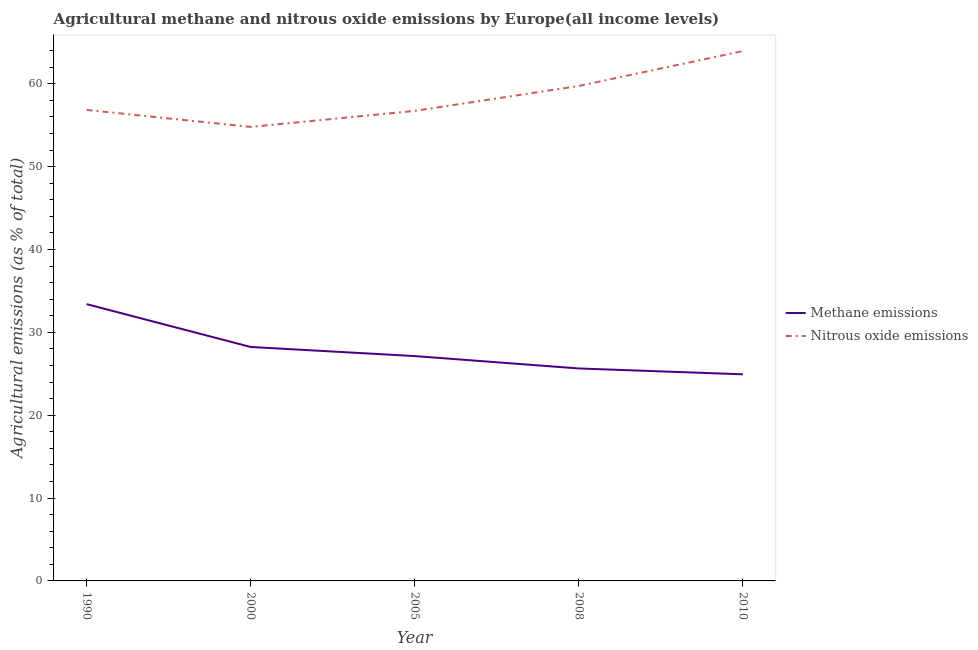Is the number of lines equal to the number of legend labels?
Offer a very short reply. Yes. What is the amount of nitrous oxide emissions in 2000?
Give a very brief answer. 54.8. Across all years, what is the maximum amount of methane emissions?
Provide a short and direct response. 33.41. Across all years, what is the minimum amount of nitrous oxide emissions?
Provide a short and direct response. 54.8. In which year was the amount of nitrous oxide emissions maximum?
Provide a succinct answer. 2010. In which year was the amount of nitrous oxide emissions minimum?
Provide a short and direct response. 2000. What is the total amount of methane emissions in the graph?
Your answer should be compact. 139.38. What is the difference between the amount of methane emissions in 2000 and that in 2010?
Ensure brevity in your answer.  3.3. What is the difference between the amount of methane emissions in 2008 and the amount of nitrous oxide emissions in 2000?
Offer a terse response. -29.16. What is the average amount of methane emissions per year?
Offer a very short reply. 27.88. In the year 2008, what is the difference between the amount of methane emissions and amount of nitrous oxide emissions?
Your response must be concise. -34.1. In how many years, is the amount of nitrous oxide emissions greater than 18 %?
Your answer should be very brief. 5. What is the ratio of the amount of methane emissions in 1990 to that in 2008?
Your answer should be very brief. 1.3. Is the amount of methane emissions in 2008 less than that in 2010?
Provide a short and direct response. No. What is the difference between the highest and the second highest amount of nitrous oxide emissions?
Make the answer very short. 4.21. What is the difference between the highest and the lowest amount of methane emissions?
Offer a very short reply. 8.47. Is the sum of the amount of nitrous oxide emissions in 1990 and 2008 greater than the maximum amount of methane emissions across all years?
Ensure brevity in your answer.  Yes. Does the amount of nitrous oxide emissions monotonically increase over the years?
Your answer should be compact. No. Is the amount of methane emissions strictly less than the amount of nitrous oxide emissions over the years?
Your answer should be very brief. Yes. How many lines are there?
Give a very brief answer. 2. How many years are there in the graph?
Make the answer very short. 5. What is the difference between two consecutive major ticks on the Y-axis?
Offer a very short reply. 10. Where does the legend appear in the graph?
Offer a very short reply. Center right. How many legend labels are there?
Provide a short and direct response. 2. What is the title of the graph?
Offer a terse response. Agricultural methane and nitrous oxide emissions by Europe(all income levels). What is the label or title of the Y-axis?
Provide a succinct answer. Agricultural emissions (as % of total). What is the Agricultural emissions (as % of total) in Methane emissions in 1990?
Keep it short and to the point. 33.41. What is the Agricultural emissions (as % of total) in Nitrous oxide emissions in 1990?
Provide a short and direct response. 56.85. What is the Agricultural emissions (as % of total) of Methane emissions in 2000?
Offer a very short reply. 28.24. What is the Agricultural emissions (as % of total) of Nitrous oxide emissions in 2000?
Make the answer very short. 54.8. What is the Agricultural emissions (as % of total) of Methane emissions in 2005?
Keep it short and to the point. 27.14. What is the Agricultural emissions (as % of total) in Nitrous oxide emissions in 2005?
Provide a succinct answer. 56.74. What is the Agricultural emissions (as % of total) in Methane emissions in 2008?
Offer a very short reply. 25.65. What is the Agricultural emissions (as % of total) in Nitrous oxide emissions in 2008?
Provide a succinct answer. 59.75. What is the Agricultural emissions (as % of total) in Methane emissions in 2010?
Provide a succinct answer. 24.94. What is the Agricultural emissions (as % of total) of Nitrous oxide emissions in 2010?
Your answer should be very brief. 63.96. Across all years, what is the maximum Agricultural emissions (as % of total) of Methane emissions?
Your answer should be compact. 33.41. Across all years, what is the maximum Agricultural emissions (as % of total) in Nitrous oxide emissions?
Provide a succinct answer. 63.96. Across all years, what is the minimum Agricultural emissions (as % of total) of Methane emissions?
Give a very brief answer. 24.94. Across all years, what is the minimum Agricultural emissions (as % of total) of Nitrous oxide emissions?
Your answer should be compact. 54.8. What is the total Agricultural emissions (as % of total) in Methane emissions in the graph?
Your answer should be very brief. 139.38. What is the total Agricultural emissions (as % of total) of Nitrous oxide emissions in the graph?
Offer a terse response. 292.1. What is the difference between the Agricultural emissions (as % of total) in Methane emissions in 1990 and that in 2000?
Give a very brief answer. 5.17. What is the difference between the Agricultural emissions (as % of total) in Nitrous oxide emissions in 1990 and that in 2000?
Your response must be concise. 2.05. What is the difference between the Agricultural emissions (as % of total) in Methane emissions in 1990 and that in 2005?
Ensure brevity in your answer.  6.27. What is the difference between the Agricultural emissions (as % of total) of Nitrous oxide emissions in 1990 and that in 2005?
Offer a very short reply. 0.12. What is the difference between the Agricultural emissions (as % of total) of Methane emissions in 1990 and that in 2008?
Offer a terse response. 7.77. What is the difference between the Agricultural emissions (as % of total) in Nitrous oxide emissions in 1990 and that in 2008?
Provide a succinct answer. -2.89. What is the difference between the Agricultural emissions (as % of total) of Methane emissions in 1990 and that in 2010?
Your response must be concise. 8.47. What is the difference between the Agricultural emissions (as % of total) in Nitrous oxide emissions in 1990 and that in 2010?
Provide a succinct answer. -7.11. What is the difference between the Agricultural emissions (as % of total) in Methane emissions in 2000 and that in 2005?
Your answer should be compact. 1.1. What is the difference between the Agricultural emissions (as % of total) in Nitrous oxide emissions in 2000 and that in 2005?
Your response must be concise. -1.93. What is the difference between the Agricultural emissions (as % of total) of Methane emissions in 2000 and that in 2008?
Your answer should be very brief. 2.59. What is the difference between the Agricultural emissions (as % of total) of Nitrous oxide emissions in 2000 and that in 2008?
Make the answer very short. -4.94. What is the difference between the Agricultural emissions (as % of total) of Methane emissions in 2000 and that in 2010?
Keep it short and to the point. 3.3. What is the difference between the Agricultural emissions (as % of total) in Nitrous oxide emissions in 2000 and that in 2010?
Provide a succinct answer. -9.16. What is the difference between the Agricultural emissions (as % of total) of Methane emissions in 2005 and that in 2008?
Offer a very short reply. 1.5. What is the difference between the Agricultural emissions (as % of total) of Nitrous oxide emissions in 2005 and that in 2008?
Offer a terse response. -3.01. What is the difference between the Agricultural emissions (as % of total) of Methane emissions in 2005 and that in 2010?
Your answer should be compact. 2.2. What is the difference between the Agricultural emissions (as % of total) in Nitrous oxide emissions in 2005 and that in 2010?
Provide a short and direct response. -7.23. What is the difference between the Agricultural emissions (as % of total) of Methane emissions in 2008 and that in 2010?
Keep it short and to the point. 0.71. What is the difference between the Agricultural emissions (as % of total) in Nitrous oxide emissions in 2008 and that in 2010?
Offer a terse response. -4.21. What is the difference between the Agricultural emissions (as % of total) in Methane emissions in 1990 and the Agricultural emissions (as % of total) in Nitrous oxide emissions in 2000?
Provide a short and direct response. -21.39. What is the difference between the Agricultural emissions (as % of total) in Methane emissions in 1990 and the Agricultural emissions (as % of total) in Nitrous oxide emissions in 2005?
Your response must be concise. -23.32. What is the difference between the Agricultural emissions (as % of total) in Methane emissions in 1990 and the Agricultural emissions (as % of total) in Nitrous oxide emissions in 2008?
Offer a very short reply. -26.33. What is the difference between the Agricultural emissions (as % of total) in Methane emissions in 1990 and the Agricultural emissions (as % of total) in Nitrous oxide emissions in 2010?
Provide a short and direct response. -30.55. What is the difference between the Agricultural emissions (as % of total) in Methane emissions in 2000 and the Agricultural emissions (as % of total) in Nitrous oxide emissions in 2005?
Your response must be concise. -28.5. What is the difference between the Agricultural emissions (as % of total) in Methane emissions in 2000 and the Agricultural emissions (as % of total) in Nitrous oxide emissions in 2008?
Provide a succinct answer. -31.51. What is the difference between the Agricultural emissions (as % of total) in Methane emissions in 2000 and the Agricultural emissions (as % of total) in Nitrous oxide emissions in 2010?
Give a very brief answer. -35.72. What is the difference between the Agricultural emissions (as % of total) of Methane emissions in 2005 and the Agricultural emissions (as % of total) of Nitrous oxide emissions in 2008?
Your answer should be compact. -32.61. What is the difference between the Agricultural emissions (as % of total) of Methane emissions in 2005 and the Agricultural emissions (as % of total) of Nitrous oxide emissions in 2010?
Provide a short and direct response. -36.82. What is the difference between the Agricultural emissions (as % of total) in Methane emissions in 2008 and the Agricultural emissions (as % of total) in Nitrous oxide emissions in 2010?
Ensure brevity in your answer.  -38.32. What is the average Agricultural emissions (as % of total) of Methane emissions per year?
Your answer should be compact. 27.88. What is the average Agricultural emissions (as % of total) in Nitrous oxide emissions per year?
Keep it short and to the point. 58.42. In the year 1990, what is the difference between the Agricultural emissions (as % of total) of Methane emissions and Agricultural emissions (as % of total) of Nitrous oxide emissions?
Your answer should be very brief. -23.44. In the year 2000, what is the difference between the Agricultural emissions (as % of total) in Methane emissions and Agricultural emissions (as % of total) in Nitrous oxide emissions?
Offer a very short reply. -26.56. In the year 2005, what is the difference between the Agricultural emissions (as % of total) of Methane emissions and Agricultural emissions (as % of total) of Nitrous oxide emissions?
Your answer should be very brief. -29.59. In the year 2008, what is the difference between the Agricultural emissions (as % of total) of Methane emissions and Agricultural emissions (as % of total) of Nitrous oxide emissions?
Keep it short and to the point. -34.1. In the year 2010, what is the difference between the Agricultural emissions (as % of total) of Methane emissions and Agricultural emissions (as % of total) of Nitrous oxide emissions?
Provide a succinct answer. -39.02. What is the ratio of the Agricultural emissions (as % of total) of Methane emissions in 1990 to that in 2000?
Offer a terse response. 1.18. What is the ratio of the Agricultural emissions (as % of total) in Nitrous oxide emissions in 1990 to that in 2000?
Keep it short and to the point. 1.04. What is the ratio of the Agricultural emissions (as % of total) in Methane emissions in 1990 to that in 2005?
Keep it short and to the point. 1.23. What is the ratio of the Agricultural emissions (as % of total) of Methane emissions in 1990 to that in 2008?
Your answer should be very brief. 1.3. What is the ratio of the Agricultural emissions (as % of total) in Nitrous oxide emissions in 1990 to that in 2008?
Keep it short and to the point. 0.95. What is the ratio of the Agricultural emissions (as % of total) of Methane emissions in 1990 to that in 2010?
Offer a very short reply. 1.34. What is the ratio of the Agricultural emissions (as % of total) of Methane emissions in 2000 to that in 2005?
Your response must be concise. 1.04. What is the ratio of the Agricultural emissions (as % of total) in Nitrous oxide emissions in 2000 to that in 2005?
Your response must be concise. 0.97. What is the ratio of the Agricultural emissions (as % of total) of Methane emissions in 2000 to that in 2008?
Your response must be concise. 1.1. What is the ratio of the Agricultural emissions (as % of total) of Nitrous oxide emissions in 2000 to that in 2008?
Provide a short and direct response. 0.92. What is the ratio of the Agricultural emissions (as % of total) in Methane emissions in 2000 to that in 2010?
Provide a short and direct response. 1.13. What is the ratio of the Agricultural emissions (as % of total) in Nitrous oxide emissions in 2000 to that in 2010?
Ensure brevity in your answer.  0.86. What is the ratio of the Agricultural emissions (as % of total) in Methane emissions in 2005 to that in 2008?
Give a very brief answer. 1.06. What is the ratio of the Agricultural emissions (as % of total) of Nitrous oxide emissions in 2005 to that in 2008?
Make the answer very short. 0.95. What is the ratio of the Agricultural emissions (as % of total) of Methane emissions in 2005 to that in 2010?
Offer a terse response. 1.09. What is the ratio of the Agricultural emissions (as % of total) in Nitrous oxide emissions in 2005 to that in 2010?
Offer a terse response. 0.89. What is the ratio of the Agricultural emissions (as % of total) in Methane emissions in 2008 to that in 2010?
Give a very brief answer. 1.03. What is the ratio of the Agricultural emissions (as % of total) of Nitrous oxide emissions in 2008 to that in 2010?
Provide a succinct answer. 0.93. What is the difference between the highest and the second highest Agricultural emissions (as % of total) of Methane emissions?
Ensure brevity in your answer.  5.17. What is the difference between the highest and the second highest Agricultural emissions (as % of total) in Nitrous oxide emissions?
Ensure brevity in your answer.  4.21. What is the difference between the highest and the lowest Agricultural emissions (as % of total) of Methane emissions?
Keep it short and to the point. 8.47. What is the difference between the highest and the lowest Agricultural emissions (as % of total) in Nitrous oxide emissions?
Give a very brief answer. 9.16. 